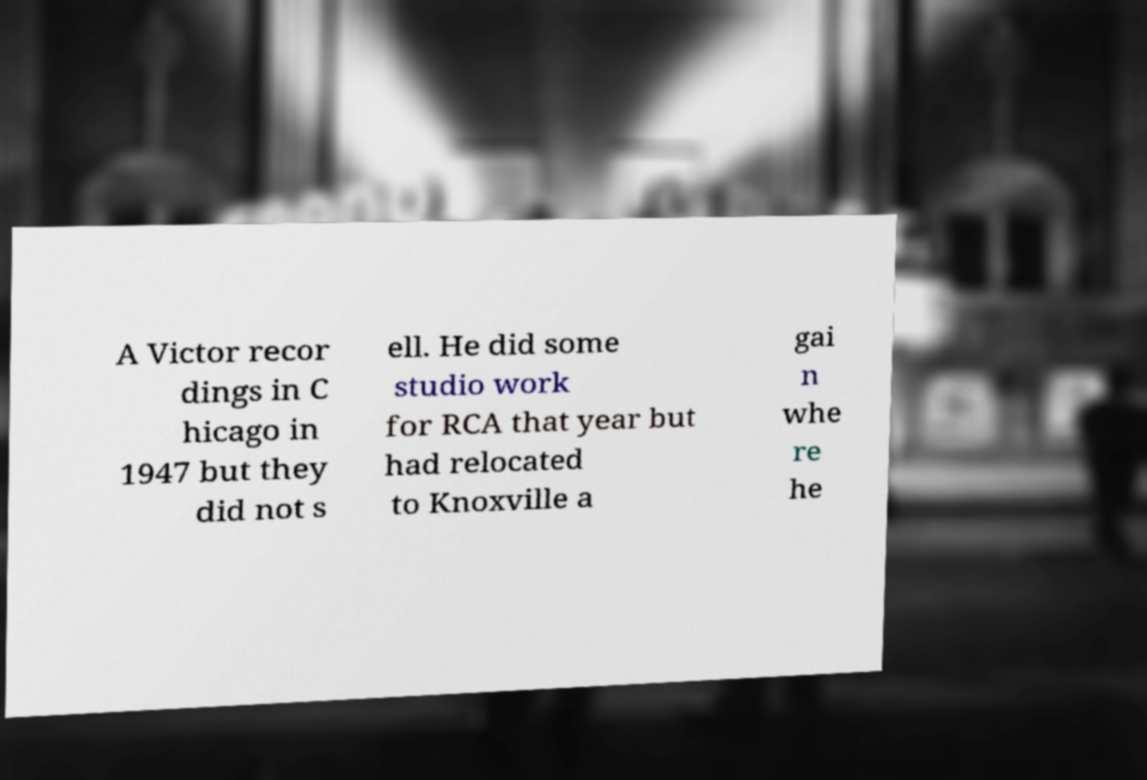There's text embedded in this image that I need extracted. Can you transcribe it verbatim? A Victor recor dings in C hicago in 1947 but they did not s ell. He did some studio work for RCA that year but had relocated to Knoxville a gai n whe re he 